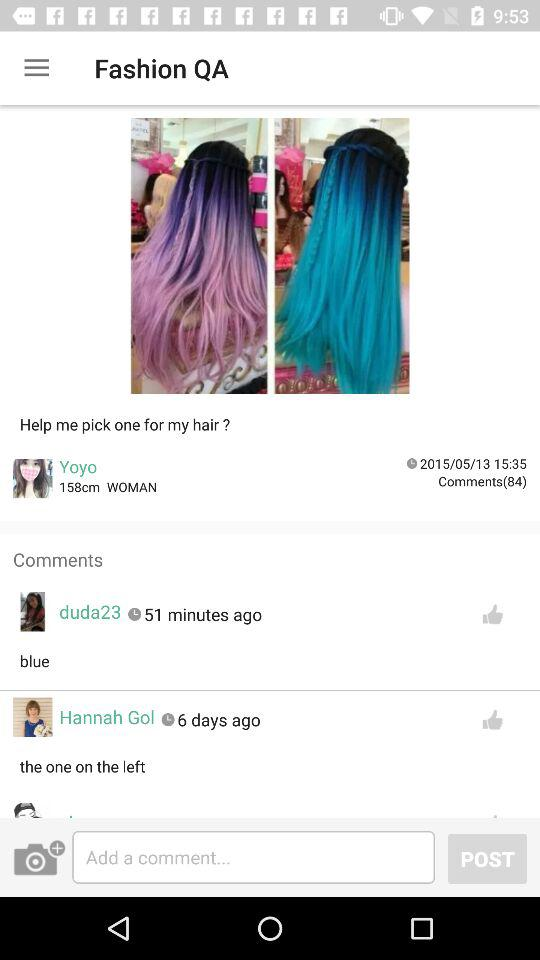How many users have commented on this post?
Answer the question using a single word or phrase. 84 